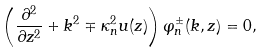Convert formula to latex. <formula><loc_0><loc_0><loc_500><loc_500>\left ( \frac { \partial ^ { 2 } } { \partial z ^ { 2 } } + k ^ { 2 } \mp \kappa _ { n } ^ { 2 } u ( z ) \right ) \varphi _ { n } ^ { \pm } ( k , z ) = 0 ,</formula> 